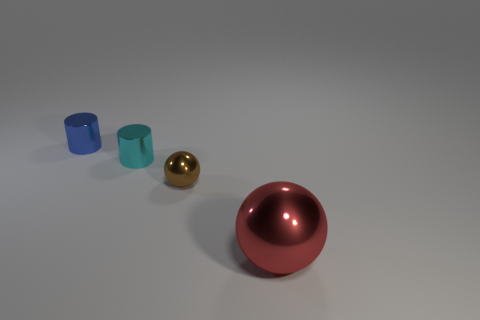Add 3 red balls. How many objects exist? 7 Add 2 cyan metal objects. How many cyan metal objects are left? 3 Add 1 tiny brown spheres. How many tiny brown spheres exist? 2 Subtract 0 green cylinders. How many objects are left? 4 Subtract all big red balls. Subtract all red shiny spheres. How many objects are left? 2 